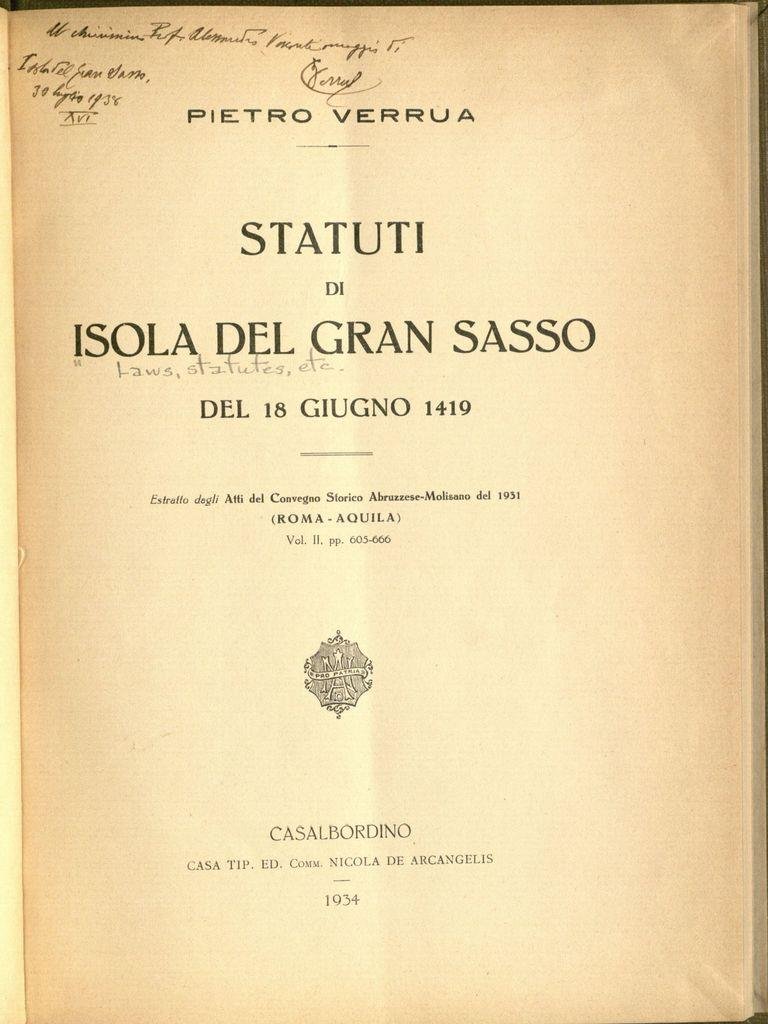<image>
Create a compact narrative representing the image presented. A book page has a signed inscription written in ink in the top corner and there is a date printed at the bottom that says 1934. 